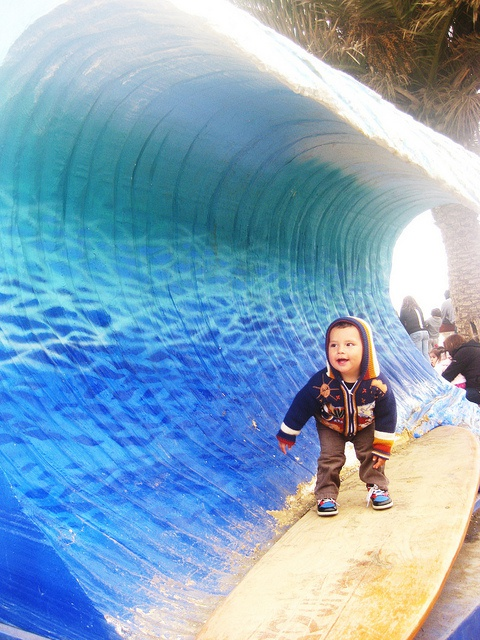Describe the objects in this image and their specific colors. I can see surfboard in white, beige, khaki, and tan tones, people in white, black, maroon, navy, and brown tones, people in white, gray, and black tones, people in white, lightgray, darkgray, and gray tones, and people in white, lightpink, gray, and violet tones in this image. 